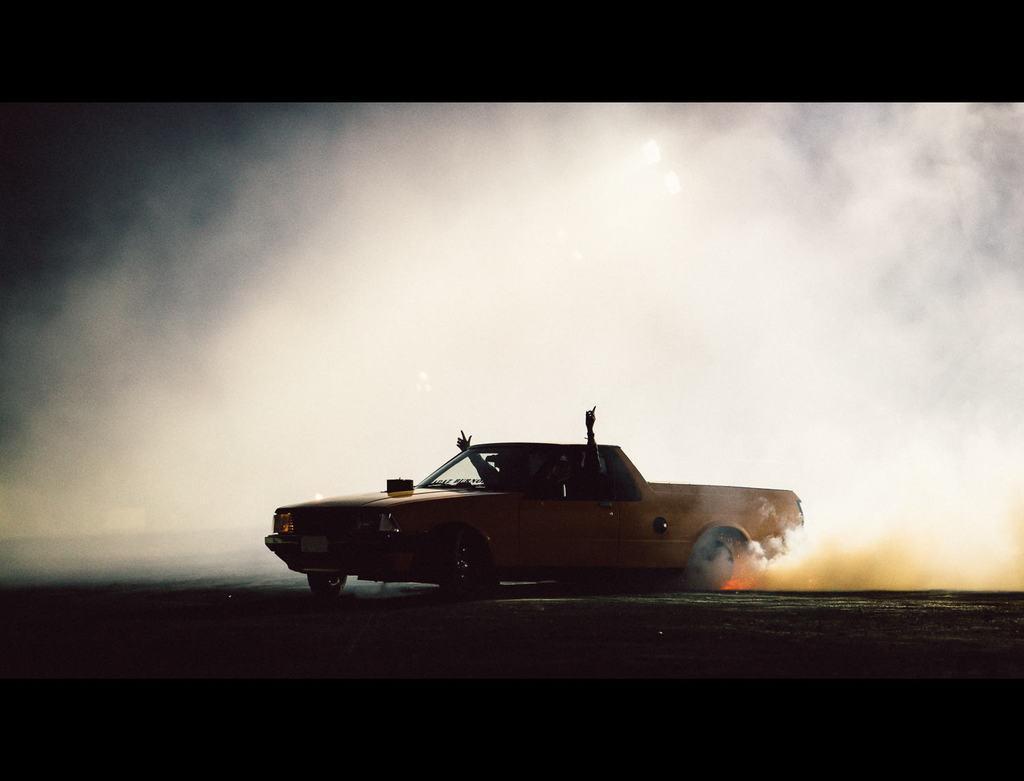Can you describe this image briefly? In this image I can see a yellow colour vehicle, smoke and here I can see two hands of people. 